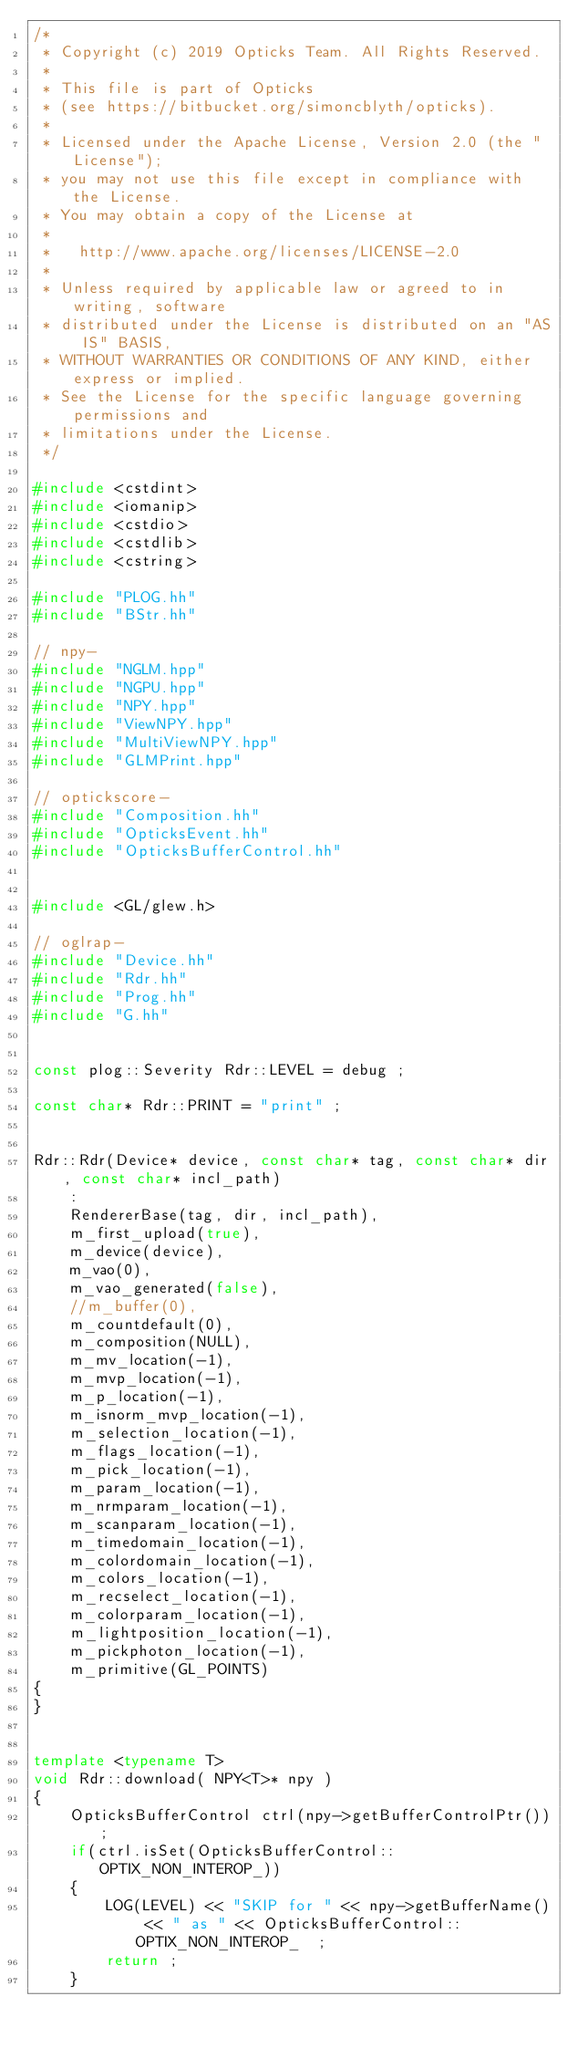Convert code to text. <code><loc_0><loc_0><loc_500><loc_500><_C++_>/*
 * Copyright (c) 2019 Opticks Team. All Rights Reserved.
 *
 * This file is part of Opticks
 * (see https://bitbucket.org/simoncblyth/opticks).
 *
 * Licensed under the Apache License, Version 2.0 (the "License"); 
 * you may not use this file except in compliance with the License.  
 * You may obtain a copy of the License at
 *
 *   http://www.apache.org/licenses/LICENSE-2.0
 *
 * Unless required by applicable law or agreed to in writing, software 
 * distributed under the License is distributed on an "AS IS" BASIS, 
 * WITHOUT WARRANTIES OR CONDITIONS OF ANY KIND, either express or implied.  
 * See the License for the specific language governing permissions and 
 * limitations under the License.
 */

#include <cstdint>
#include <iomanip>
#include <cstdio>
#include <cstdlib>
#include <cstring>

#include "PLOG.hh"
#include "BStr.hh"

// npy-
#include "NGLM.hpp"
#include "NGPU.hpp"
#include "NPY.hpp"
#include "ViewNPY.hpp"
#include "MultiViewNPY.hpp"
#include "GLMPrint.hpp"

// optickscore-
#include "Composition.hh"
#include "OpticksEvent.hh"
#include "OpticksBufferControl.hh"


#include <GL/glew.h>

// oglrap-
#include "Device.hh"
#include "Rdr.hh"
#include "Prog.hh"
#include "G.hh"


const plog::Severity Rdr::LEVEL = debug ; 

const char* Rdr::PRINT = "print" ; 


Rdr::Rdr(Device* device, const char* tag, const char* dir, const char* incl_path)
    :
    RendererBase(tag, dir, incl_path),  
    m_first_upload(true),
    m_device(device),
    m_vao(0),
    m_vao_generated(false),
    //m_buffer(0),
    m_countdefault(0),
    m_composition(NULL),
    m_mv_location(-1),
    m_mvp_location(-1),
    m_p_location(-1),
    m_isnorm_mvp_location(-1),
    m_selection_location(-1),
    m_flags_location(-1),
    m_pick_location(-1),
    m_param_location(-1),
    m_nrmparam_location(-1),
    m_scanparam_location(-1),
    m_timedomain_location(-1),
    m_colordomain_location(-1),
    m_colors_location(-1),
    m_recselect_location(-1),
    m_colorparam_location(-1),
    m_lightposition_location(-1),
    m_pickphoton_location(-1),
    m_primitive(GL_POINTS)
{
}


template <typename T>
void Rdr::download( NPY<T>* npy )
{
    OpticksBufferControl ctrl(npy->getBufferControlPtr());
    if(ctrl.isSet(OpticksBufferControl::OPTIX_NON_INTEROP_))
    {
        LOG(LEVEL) << "SKIP for " << npy->getBufferName() << " as " << OpticksBufferControl::OPTIX_NON_INTEROP_  ;
        return ; 
    }
</code> 